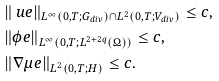Convert formula to latex. <formula><loc_0><loc_0><loc_500><loc_500>& \| \ u e \| _ { L ^ { \infty } ( 0 , T ; G _ { d i v } ) \cap L ^ { 2 } ( 0 , T ; V _ { d i v } ) } \leq c , \\ & \| \phi e \| _ { L ^ { \infty } ( 0 , T ; L ^ { 2 + 2 q } ( \Omega ) ) } \leq c , \\ & \| \nabla \mu e \| _ { L ^ { 2 } ( 0 , T ; H ) } \leq c .</formula> 